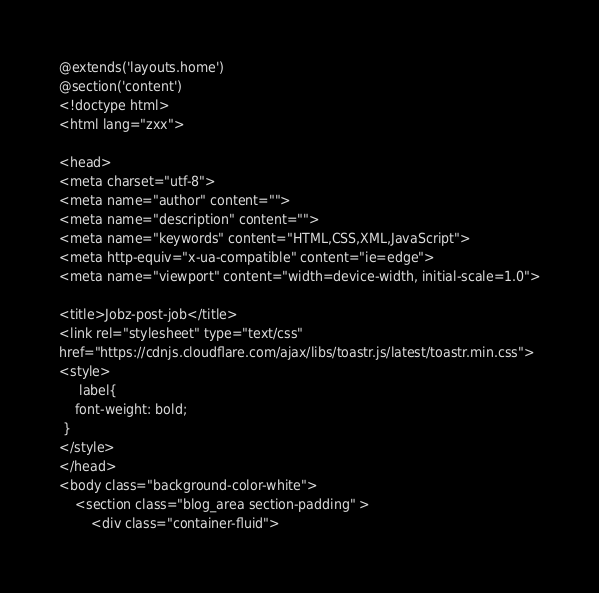Convert code to text. <code><loc_0><loc_0><loc_500><loc_500><_PHP_>@extends('layouts.home')
@section('content')
<!doctype html>
<html lang="zxx">

<head>
<meta charset="utf-8">
<meta name="author" content="">
<meta name="description" content="">
<meta name="keywords" content="HTML,CSS,XML,JavaScript">
<meta http-equiv="x-ua-compatible" content="ie=edge">
<meta name="viewport" content="width=device-width, initial-scale=1.0">

<title>Jobz-post-job</title>
<link rel="stylesheet" type="text/css" 
href="https://cdnjs.cloudflare.com/ajax/libs/toastr.js/latest/toastr.min.css">
<style>
     label{
    font-weight: bold;
 }
</style>
</head>
<body class="background-color-white">
    <section class="blog_area section-padding" >
        <div class="container-fluid"></code> 